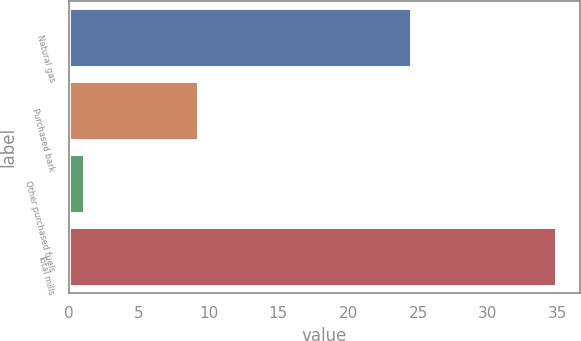Convert chart. <chart><loc_0><loc_0><loc_500><loc_500><bar_chart><fcel>Natural gas<fcel>Purchased bark<fcel>Other purchased fuels<fcel>Total mills<nl><fcel>24.5<fcel>9.27<fcel>1.1<fcel>34.87<nl></chart> 